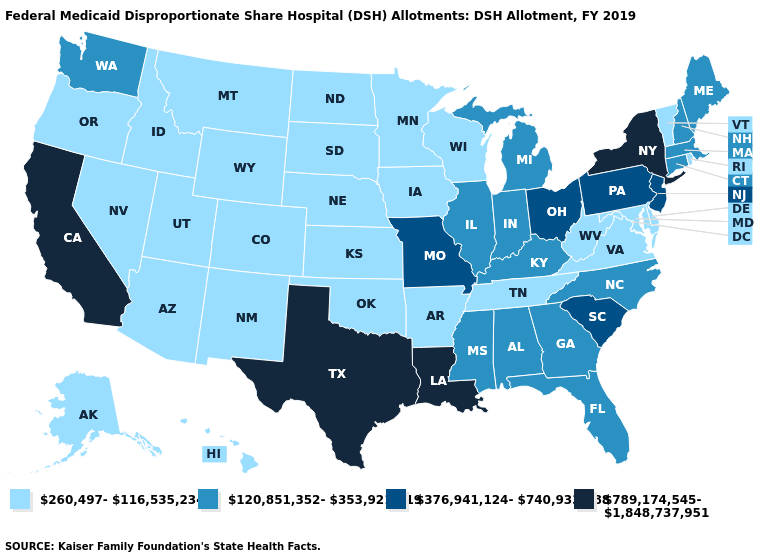What is the value of North Dakota?
Write a very short answer. 260,497-116,535,234. Among the states that border Nevada , does California have the lowest value?
Short answer required. No. Name the states that have a value in the range 120,851,352-353,921,819?
Keep it brief. Alabama, Connecticut, Florida, Georgia, Illinois, Indiana, Kentucky, Maine, Massachusetts, Michigan, Mississippi, New Hampshire, North Carolina, Washington. What is the lowest value in the USA?
Concise answer only. 260,497-116,535,234. Does Louisiana have the same value as Texas?
Short answer required. Yes. What is the highest value in the USA?
Write a very short answer. 789,174,545-1,848,737,951. Does the first symbol in the legend represent the smallest category?
Concise answer only. Yes. What is the value of Kansas?
Concise answer only. 260,497-116,535,234. Does Oklahoma have the highest value in the USA?
Answer briefly. No. What is the value of New York?
Concise answer only. 789,174,545-1,848,737,951. Name the states that have a value in the range 789,174,545-1,848,737,951?
Concise answer only. California, Louisiana, New York, Texas. What is the value of Nevada?
Be succinct. 260,497-116,535,234. Name the states that have a value in the range 376,941,124-740,933,888?
Give a very brief answer. Missouri, New Jersey, Ohio, Pennsylvania, South Carolina. Name the states that have a value in the range 376,941,124-740,933,888?
Give a very brief answer. Missouri, New Jersey, Ohio, Pennsylvania, South Carolina. Does Connecticut have a lower value than Florida?
Quick response, please. No. 